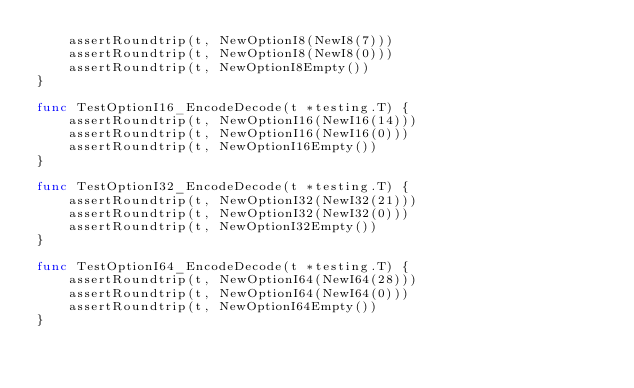Convert code to text. <code><loc_0><loc_0><loc_500><loc_500><_Go_>	assertRoundtrip(t, NewOptionI8(NewI8(7)))
	assertRoundtrip(t, NewOptionI8(NewI8(0)))
	assertRoundtrip(t, NewOptionI8Empty())
}

func TestOptionI16_EncodeDecode(t *testing.T) {
	assertRoundtrip(t, NewOptionI16(NewI16(14)))
	assertRoundtrip(t, NewOptionI16(NewI16(0)))
	assertRoundtrip(t, NewOptionI16Empty())
}

func TestOptionI32_EncodeDecode(t *testing.T) {
	assertRoundtrip(t, NewOptionI32(NewI32(21)))
	assertRoundtrip(t, NewOptionI32(NewI32(0)))
	assertRoundtrip(t, NewOptionI32Empty())
}

func TestOptionI64_EncodeDecode(t *testing.T) {
	assertRoundtrip(t, NewOptionI64(NewI64(28)))
	assertRoundtrip(t, NewOptionI64(NewI64(0)))
	assertRoundtrip(t, NewOptionI64Empty())
}
</code> 